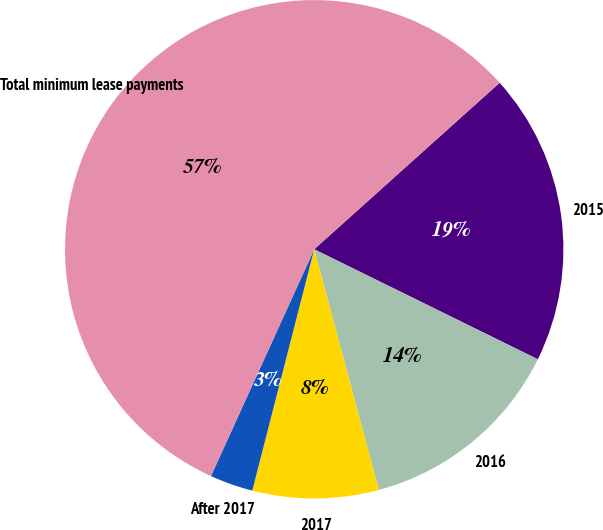<chart> <loc_0><loc_0><loc_500><loc_500><pie_chart><fcel>2015<fcel>2016<fcel>2017<fcel>After 2017<fcel>Total minimum lease payments<nl><fcel>18.92%<fcel>13.55%<fcel>8.17%<fcel>2.8%<fcel>56.55%<nl></chart> 